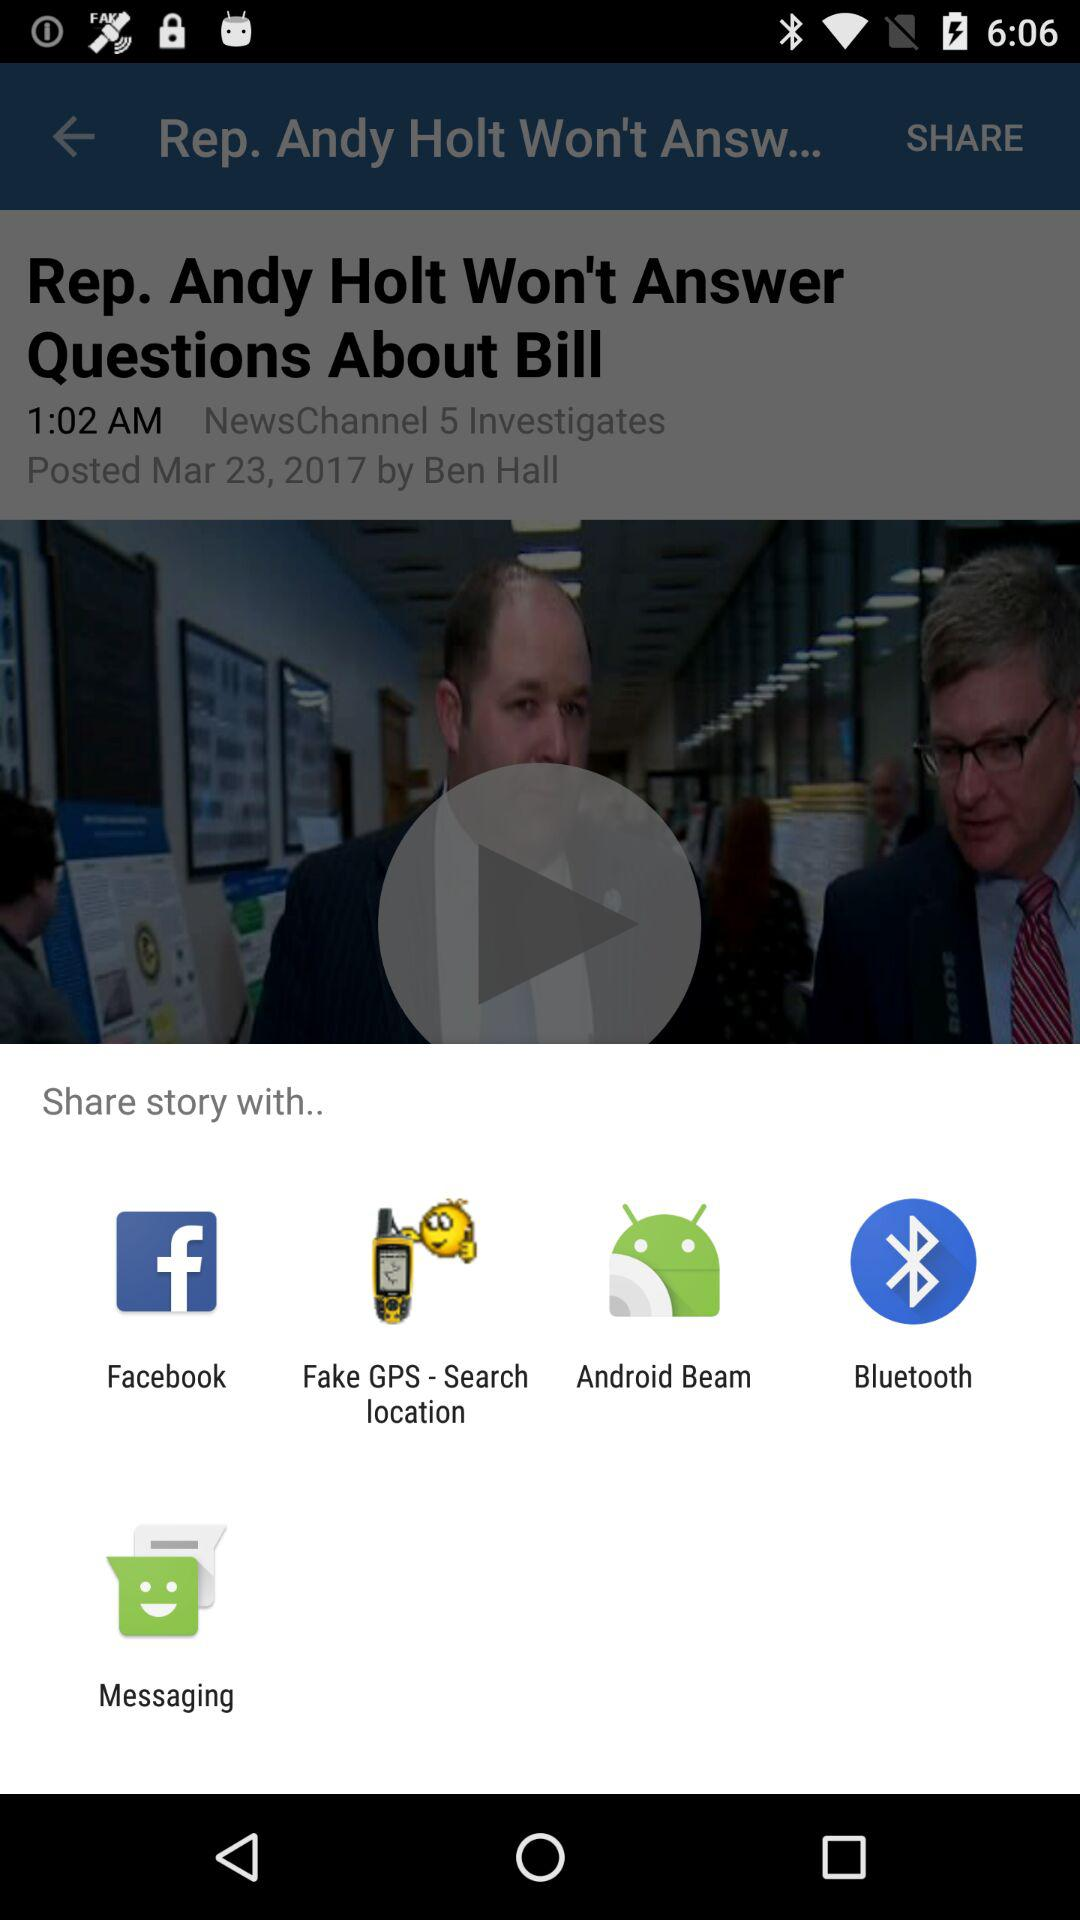How many items are in the share menu?
Answer the question using a single word or phrase. 5 